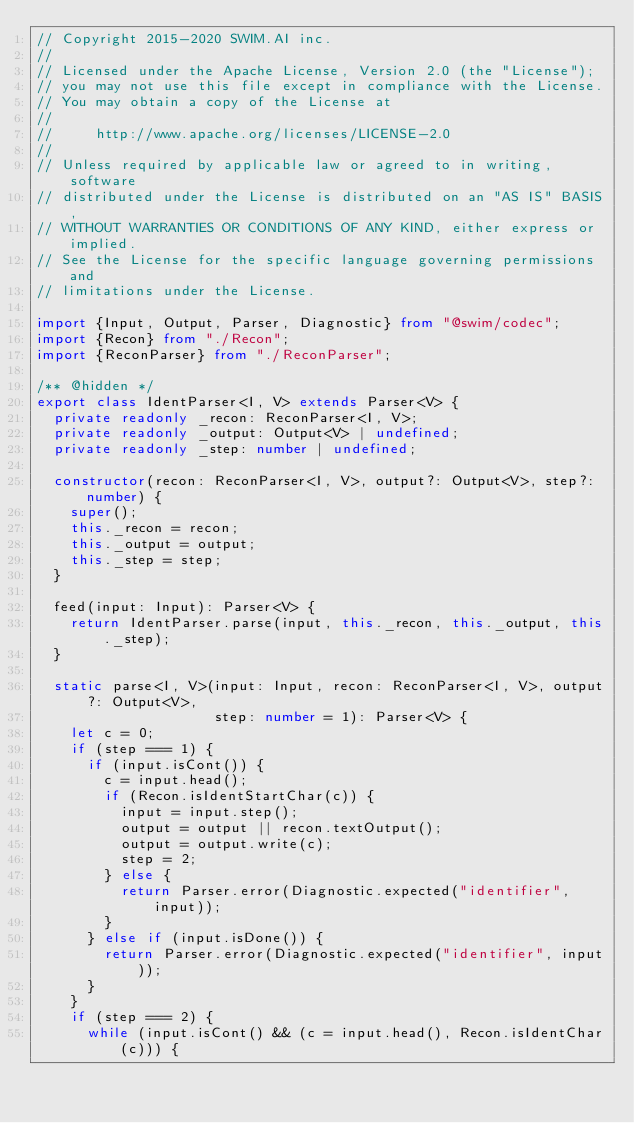<code> <loc_0><loc_0><loc_500><loc_500><_TypeScript_>// Copyright 2015-2020 SWIM.AI inc.
//
// Licensed under the Apache License, Version 2.0 (the "License");
// you may not use this file except in compliance with the License.
// You may obtain a copy of the License at
//
//     http://www.apache.org/licenses/LICENSE-2.0
//
// Unless required by applicable law or agreed to in writing, software
// distributed under the License is distributed on an "AS IS" BASIS,
// WITHOUT WARRANTIES OR CONDITIONS OF ANY KIND, either express or implied.
// See the License for the specific language governing permissions and
// limitations under the License.

import {Input, Output, Parser, Diagnostic} from "@swim/codec";
import {Recon} from "./Recon";
import {ReconParser} from "./ReconParser";

/** @hidden */
export class IdentParser<I, V> extends Parser<V> {
  private readonly _recon: ReconParser<I, V>;
  private readonly _output: Output<V> | undefined;
  private readonly _step: number | undefined;

  constructor(recon: ReconParser<I, V>, output?: Output<V>, step?: number) {
    super();
    this._recon = recon;
    this._output = output;
    this._step = step;
  }

  feed(input: Input): Parser<V> {
    return IdentParser.parse(input, this._recon, this._output, this._step);
  }

  static parse<I, V>(input: Input, recon: ReconParser<I, V>, output?: Output<V>,
                     step: number = 1): Parser<V> {
    let c = 0;
    if (step === 1) {
      if (input.isCont()) {
        c = input.head();
        if (Recon.isIdentStartChar(c)) {
          input = input.step();
          output = output || recon.textOutput();
          output = output.write(c);
          step = 2;
        } else {
          return Parser.error(Diagnostic.expected("identifier", input));
        }
      } else if (input.isDone()) {
        return Parser.error(Diagnostic.expected("identifier", input));
      }
    }
    if (step === 2) {
      while (input.isCont() && (c = input.head(), Recon.isIdentChar(c))) {</code> 